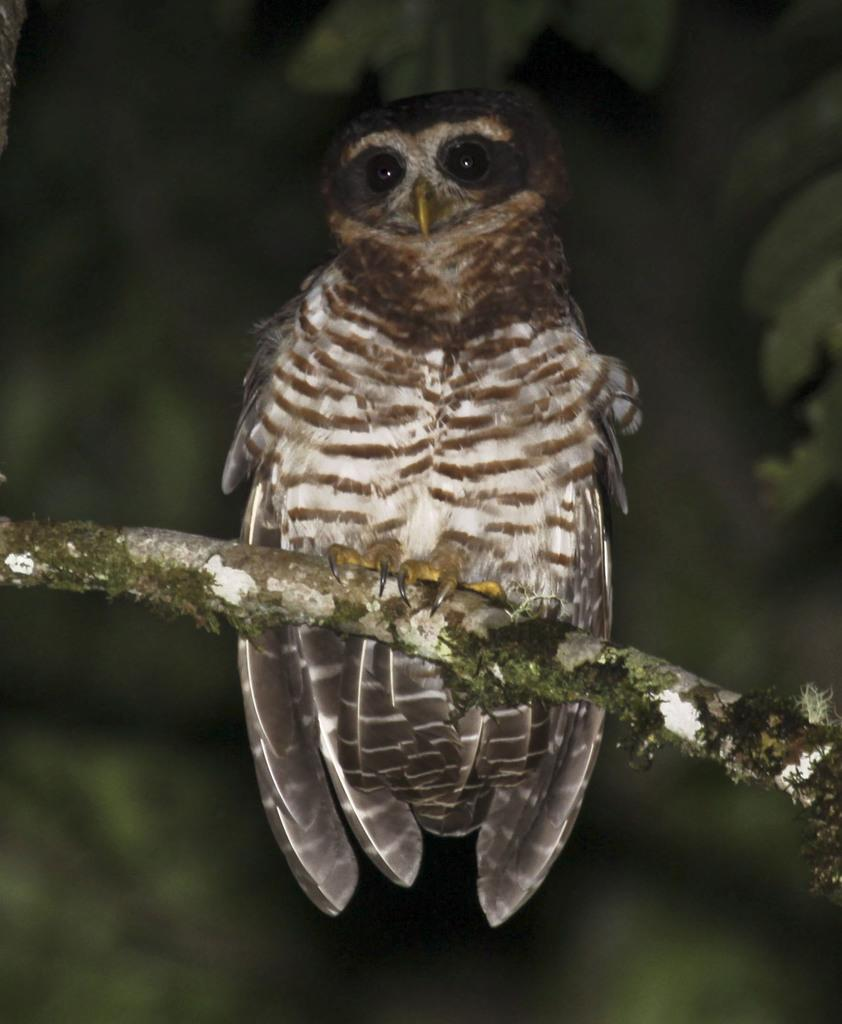What animal is present in the image? There is an owl in the image. Where is the owl located? The owl is sitting on a stem. Can you describe the background of the image? The background of the image is blurry. What type of test is being conducted in the image? There is no test being conducted in the image; it features an owl sitting on a stem with a blurry background. 